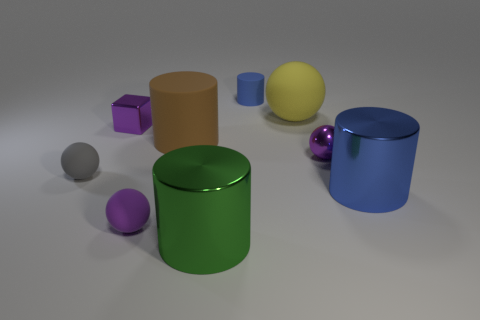Subtract 1 cylinders. How many cylinders are left? 3 Add 1 matte spheres. How many objects exist? 10 Subtract all blocks. How many objects are left? 8 Add 8 large balls. How many large balls are left? 9 Add 5 yellow spheres. How many yellow spheres exist? 6 Subtract 1 gray spheres. How many objects are left? 8 Subtract all gray balls. Subtract all large green metallic cylinders. How many objects are left? 7 